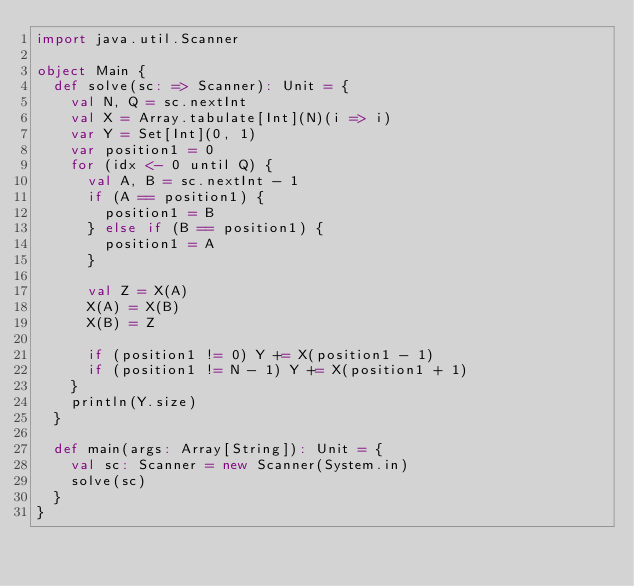Convert code to text. <code><loc_0><loc_0><loc_500><loc_500><_Scala_>import java.util.Scanner

object Main {
  def solve(sc: => Scanner): Unit = {
    val N, Q = sc.nextInt
    val X = Array.tabulate[Int](N)(i => i)
    var Y = Set[Int](0, 1)
    var position1 = 0
    for (idx <- 0 until Q) {
      val A, B = sc.nextInt - 1
      if (A == position1) {
        position1 = B
      } else if (B == position1) {
        position1 = A
      }

      val Z = X(A)
      X(A) = X(B)
      X(B) = Z

      if (position1 != 0) Y += X(position1 - 1)
      if (position1 != N - 1) Y += X(position1 + 1)
    }
    println(Y.size)
  }

  def main(args: Array[String]): Unit = {
    val sc: Scanner = new Scanner(System.in)
    solve(sc)
  }
}</code> 